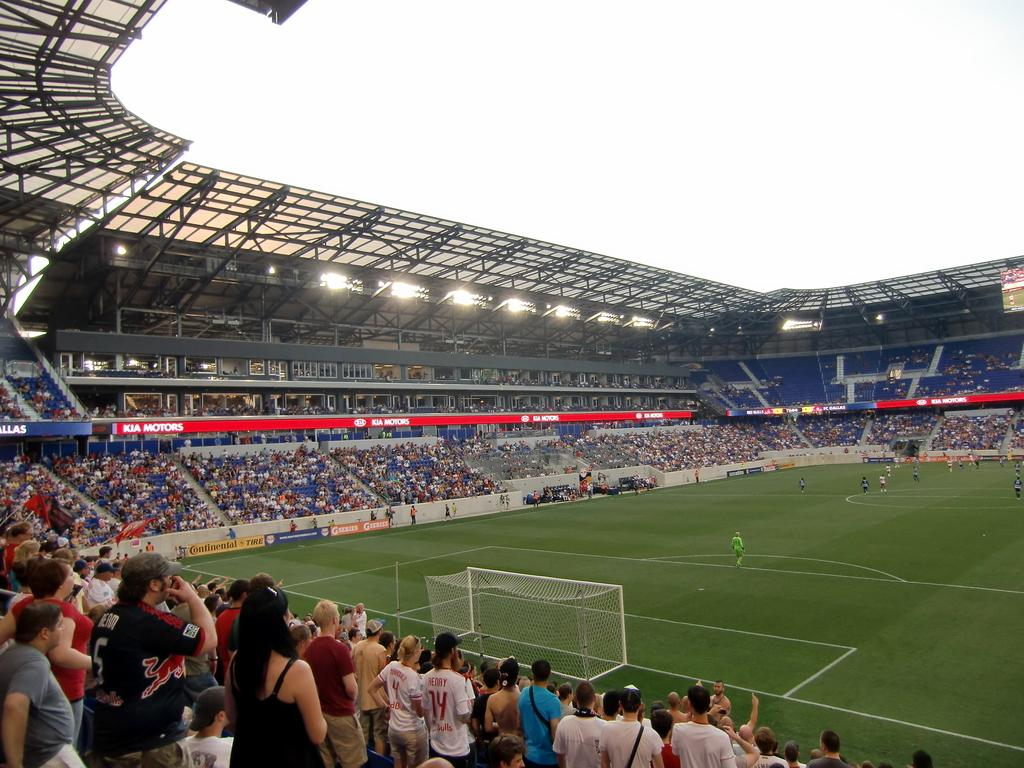<image>
Give a short and clear explanation of the subsequent image. a baseball field with banners for kia motors 